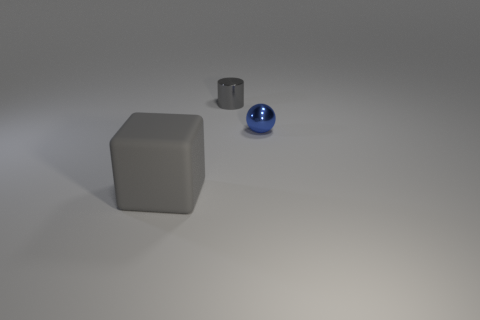The other shiny object that is the same color as the big object is what shape?
Your answer should be compact. Cylinder. What number of yellow things are either cylinders or rubber cubes?
Give a very brief answer. 0. What is the shape of the thing on the left side of the gray thing that is behind the large thing?
Give a very brief answer. Cube. What is the shape of the other object that is the same size as the gray shiny object?
Your answer should be compact. Sphere. Are there any balls of the same color as the large block?
Your answer should be very brief. No. Are there an equal number of large gray things to the left of the blue thing and large gray blocks on the right side of the small gray metal object?
Your response must be concise. No. There is a rubber thing; is it the same shape as the small metallic object that is in front of the gray metallic object?
Provide a succinct answer. No. How many other things are made of the same material as the tiny gray cylinder?
Your answer should be very brief. 1. There is a gray matte thing; are there any small gray things on the left side of it?
Provide a succinct answer. No. There is a gray metallic object; does it have the same size as the thing that is in front of the small blue metallic sphere?
Your answer should be compact. No. 